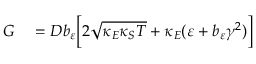<formula> <loc_0><loc_0><loc_500><loc_500>\begin{array} { r l } { G } & = D b _ { \varepsilon } \left [ 2 \sqrt { \kappa _ { E } \kappa _ { S } T } + \kappa _ { E } ( \varepsilon + b _ { \varepsilon } \gamma ^ { 2 } ) \right ] } \end{array}</formula> 